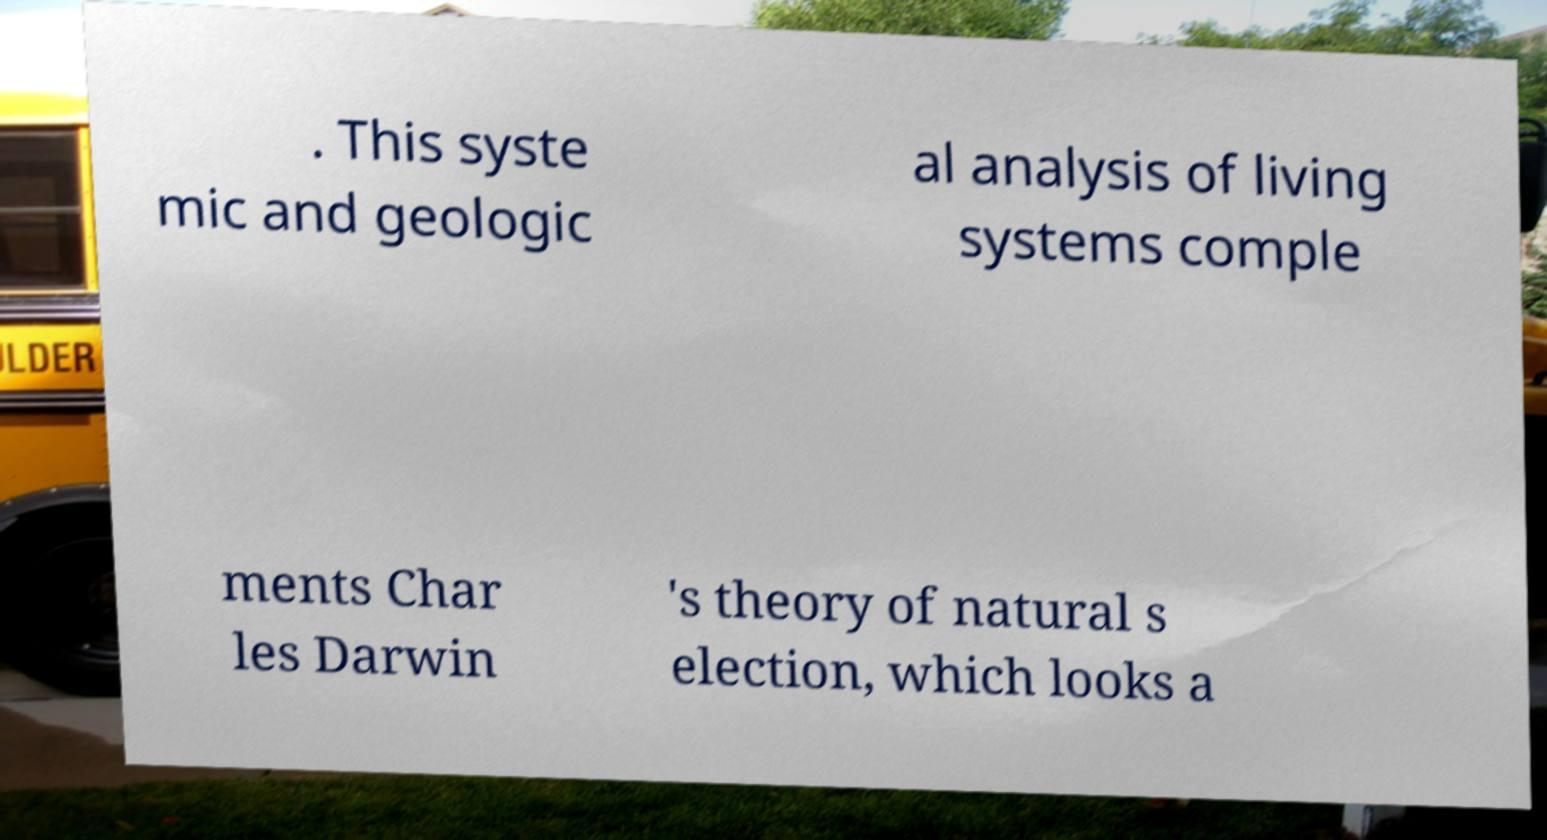Could you assist in decoding the text presented in this image and type it out clearly? . This syste mic and geologic al analysis of living systems comple ments Char les Darwin 's theory of natural s election, which looks a 